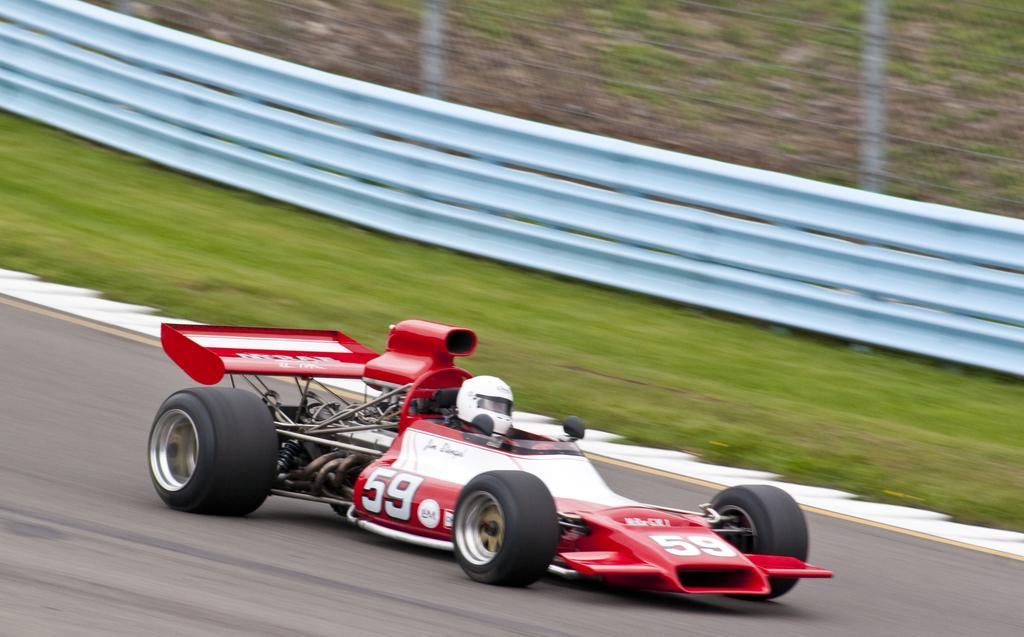Who is present in the image? There is a person in the image. What is the person wearing? The person is wearing a helmet. What type of vehicle is the person sitting in? The person is sitting in a sports car. Where is the sports car located? The sports car is on the road. What can be seen on the backside of the image? There is grass and a metal fence visible on the backside of the image. What type of meal is being prepared in the sports car? There is no meal being prepared in the sports car; the image only shows a person wearing a helmet and sitting in the vehicle. 